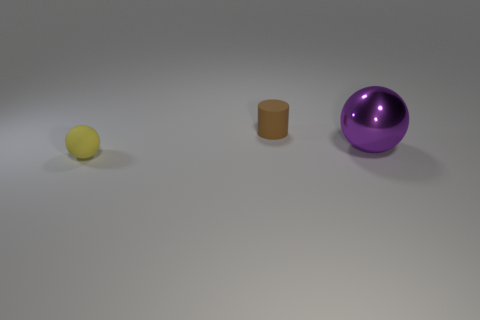Add 1 small purple metal cubes. How many objects exist? 4 Subtract all cylinders. How many objects are left? 2 Subtract 1 balls. How many balls are left? 1 Add 2 small balls. How many small balls exist? 3 Subtract all yellow spheres. How many spheres are left? 1 Subtract 0 green spheres. How many objects are left? 3 Subtract all purple cylinders. Subtract all purple spheres. How many cylinders are left? 1 Subtract all yellow cubes. How many gray spheres are left? 0 Subtract all big objects. Subtract all yellow rubber objects. How many objects are left? 1 Add 1 purple metallic objects. How many purple metallic objects are left? 2 